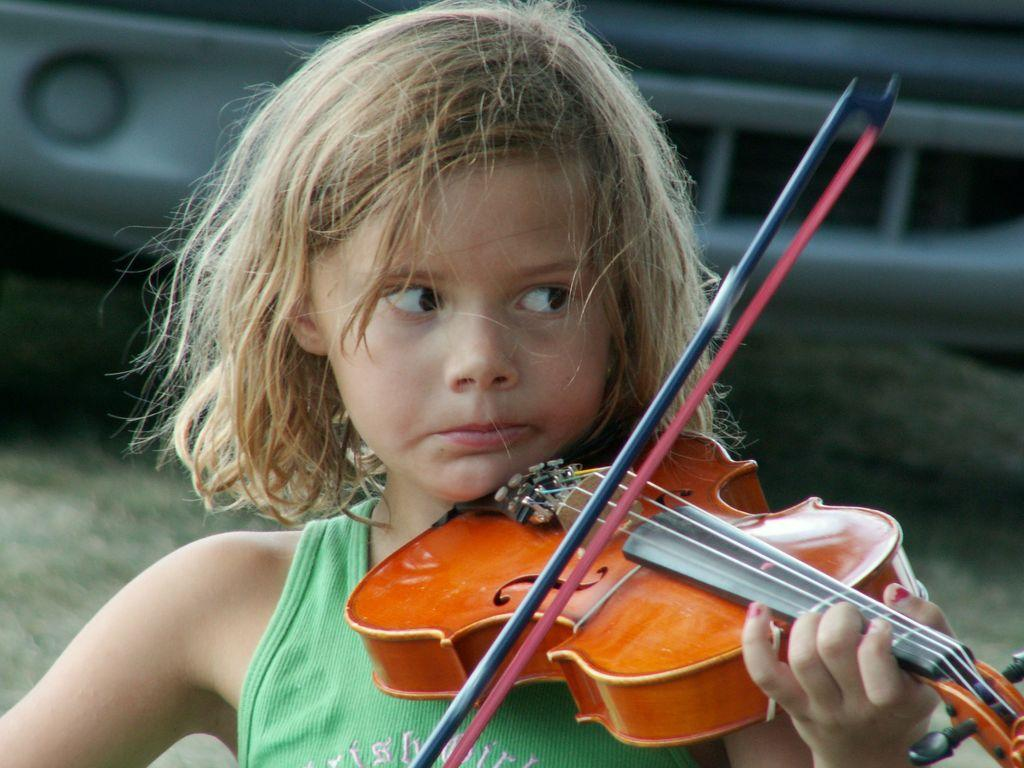Who is the main subject in the image? There is a girl in the image. What is the girl holding in the image? The girl is holding a violin. What is the girl doing with the violin? The girl is playing the violin. Can you describe the girl's hairstyle? The girl has short hair. What can be seen in the background of the image? There is a car in the background of the image. What type of insurance does the girl have for her violin in the image? There is no information about insurance for the violin in the image. Can you tell me how many pots are on the ground in the image? There are no pots visible in the image. 